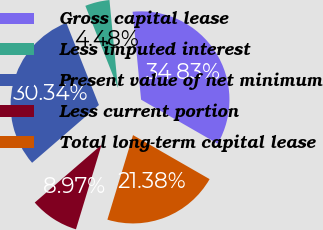<chart> <loc_0><loc_0><loc_500><loc_500><pie_chart><fcel>Gross capital lease<fcel>Less imputed interest<fcel>Present value of net minimum<fcel>Less current portion<fcel>Total long-term capital lease<nl><fcel>34.83%<fcel>4.48%<fcel>30.34%<fcel>8.97%<fcel>21.38%<nl></chart> 